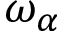<formula> <loc_0><loc_0><loc_500><loc_500>\omega _ { \alpha }</formula> 